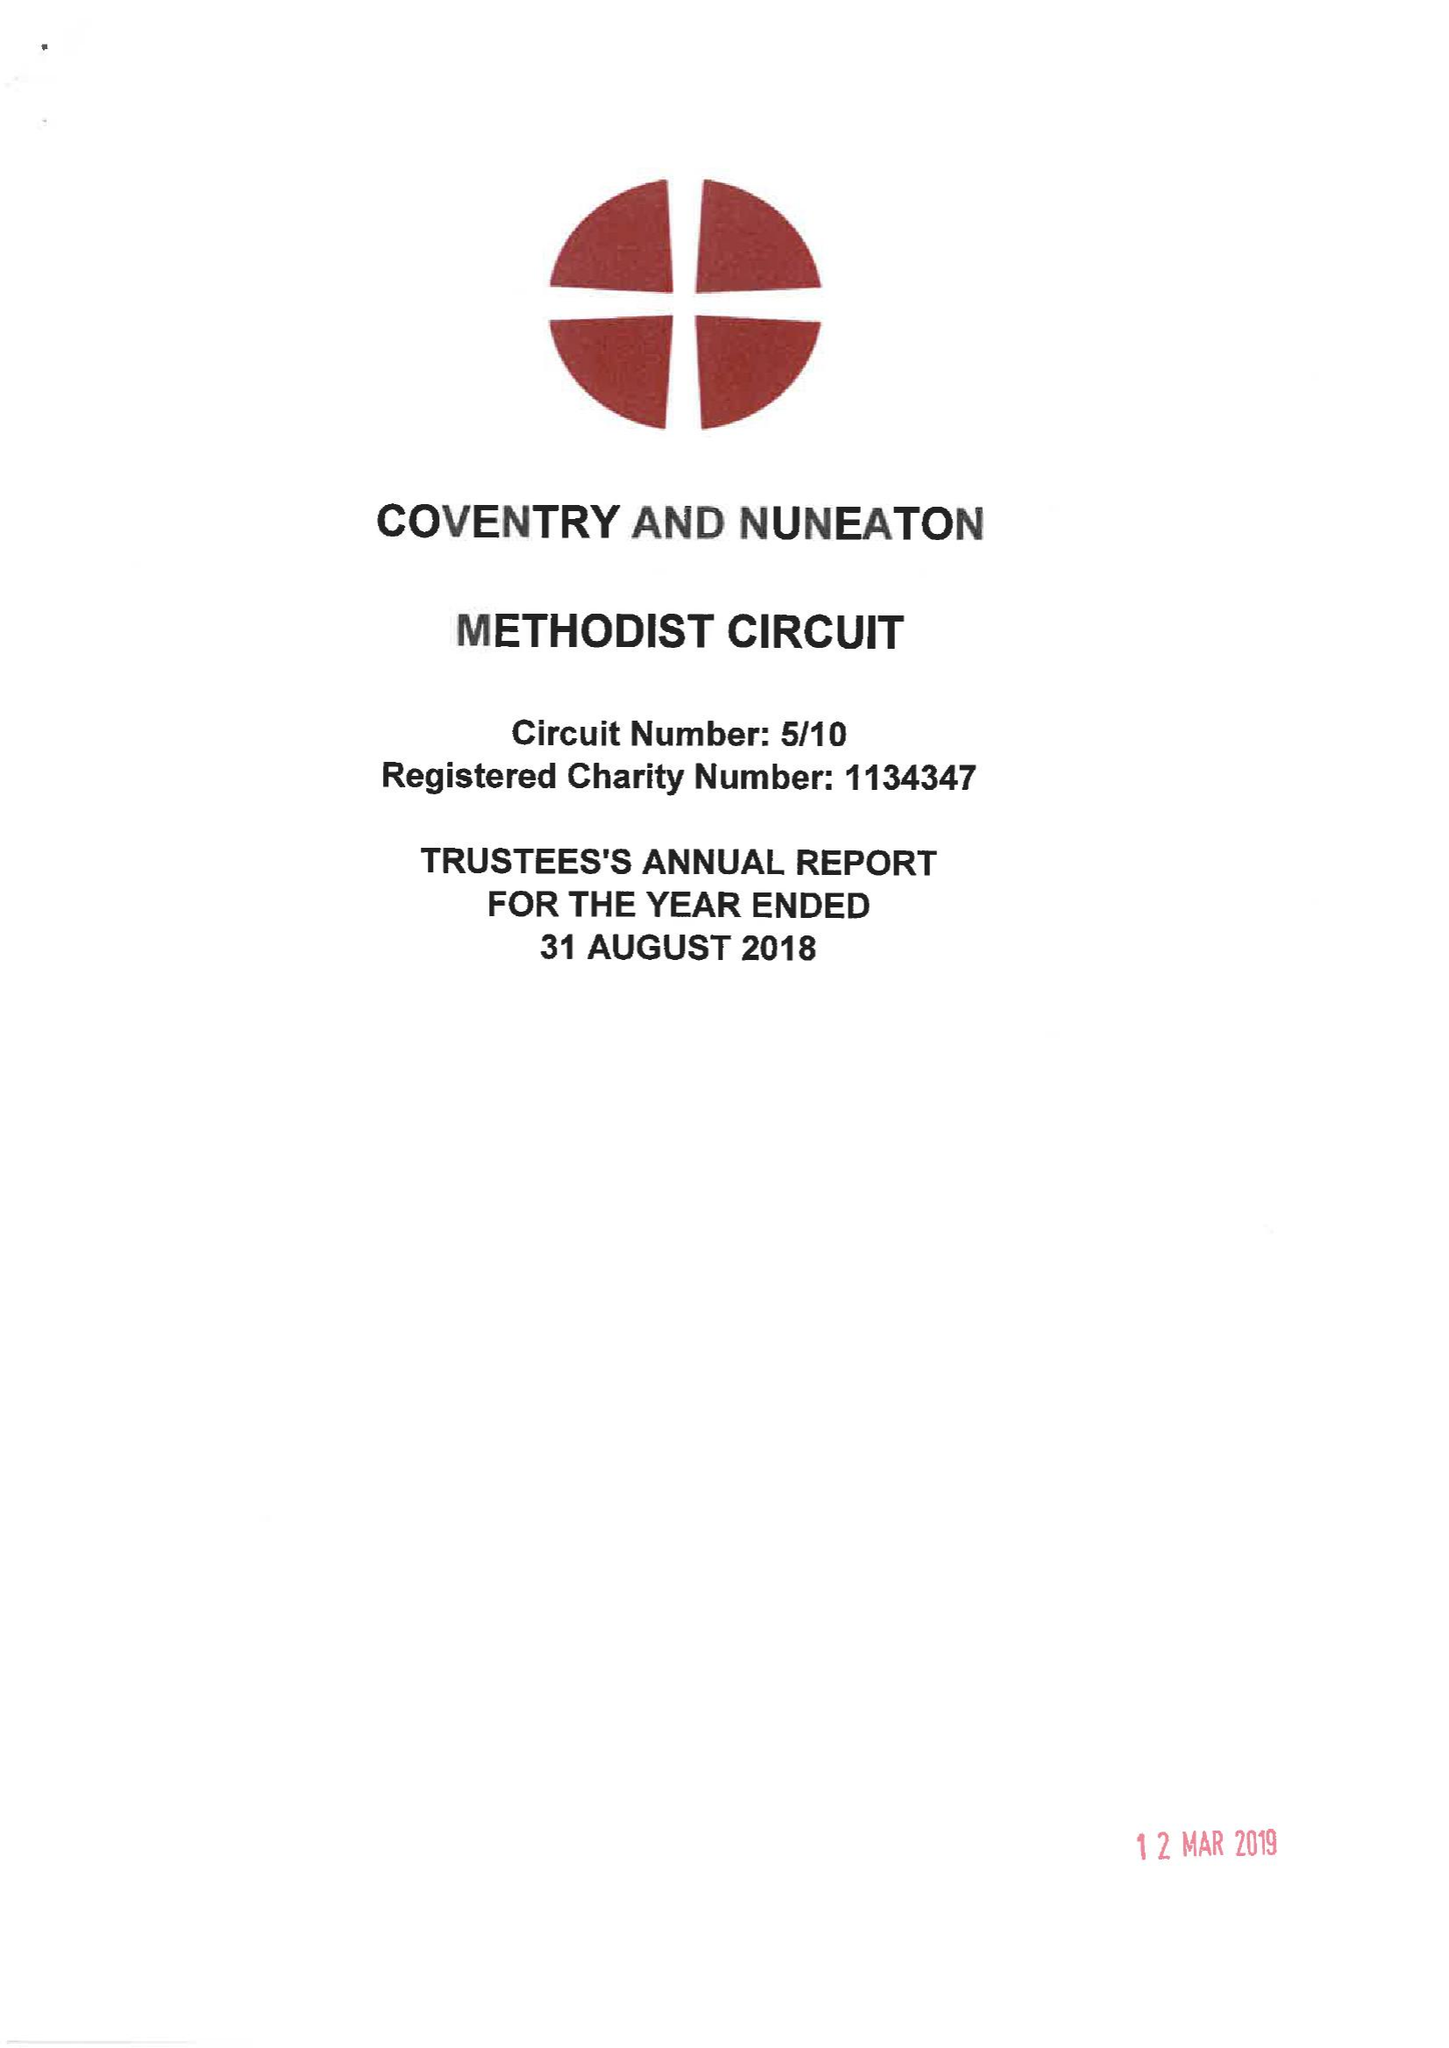What is the value for the income_annually_in_british_pounds?
Answer the question using a single word or phrase. 282091.00 